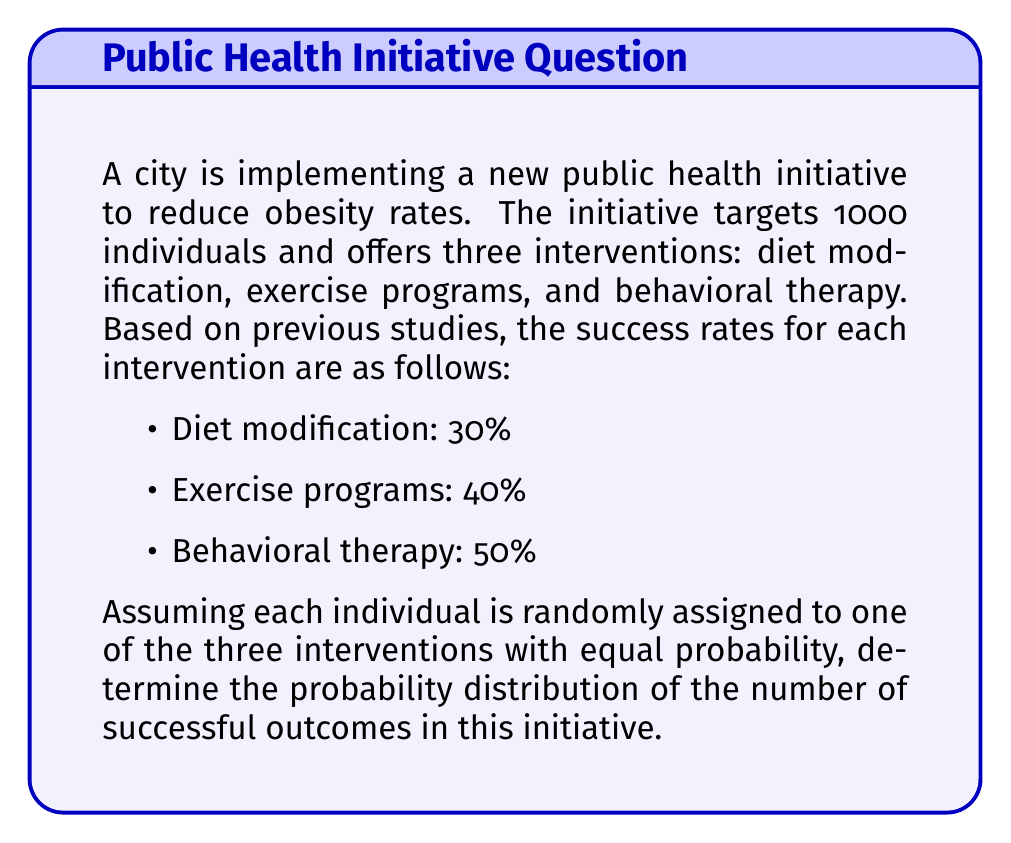Solve this math problem. To solve this problem, we'll use the concept of a binomial distribution, as each individual's outcome can be considered a Bernoulli trial (success or failure).

Step 1: Calculate the overall probability of success for a single individual.

The probability of success for each intervention:
$p_1 = 0.30$ (diet modification)
$p_2 = 0.40$ (exercise programs)
$p_3 = 0.50$ (behavioral therapy)

The probability of being assigned to each intervention:
$P(\text{intervention}) = \frac{1}{3}$ (equal probability)

Overall probability of success:
$$p = p_1 \cdot \frac{1}{3} + p_2 \cdot \frac{1}{3} + p_3 \cdot \frac{1}{3} = \frac{0.30 + 0.40 + 0.50}{3} = 0.40$$

Step 2: Identify the parameters of the binomial distribution.

Number of trials: $n = 1000$ (total individuals)
Probability of success: $p = 0.40$
Probability of failure: $q = 1 - p = 0.60$

Step 3: Express the probability distribution using the binomial probability mass function.

The probability of exactly $k$ successes in $n$ trials is given by:

$$P(X = k) = \binom{n}{k} p^k q^{n-k}$$

Where:
$X$ is the random variable representing the number of successful outcomes
$k$ is the number of successes (0 ≤ k ≤ 1000)
$\binom{n}{k}$ is the binomial coefficient

Therefore, the probability distribution of the number of successful outcomes is:

$$P(X = k) = \binom{1000}{k} (0.40)^k (0.60)^{1000-k}$$

For $k = 0, 1, 2, ..., 1000$
Answer: $P(X = k) = \binom{1000}{k} (0.40)^k (0.60)^{1000-k}$, where $0 \leq k \leq 1000$ 